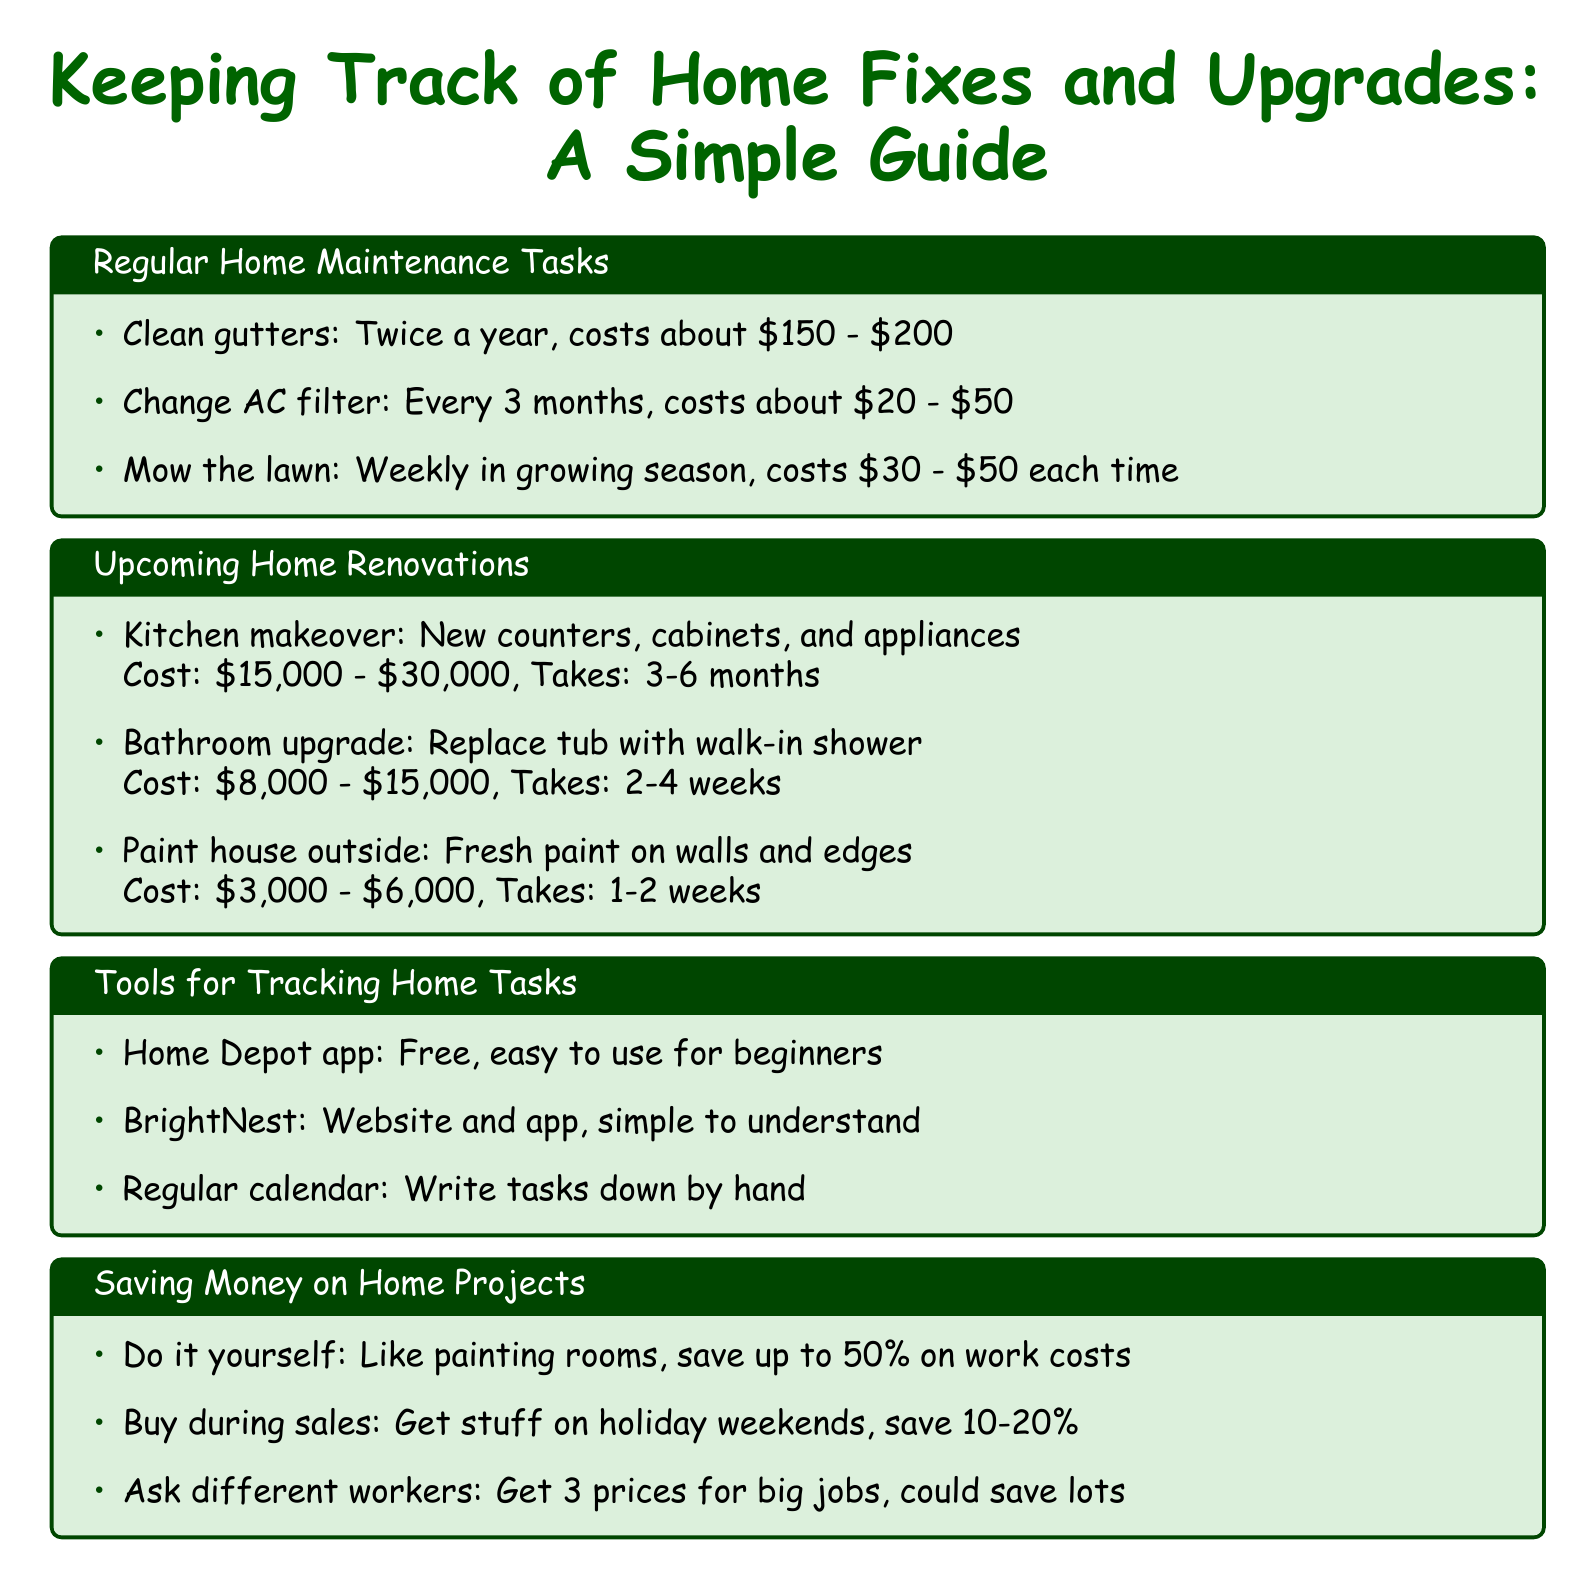What is the cost to clean gutters? The cost to clean gutters is mentioned in the document, which is $150 - $200.
Answer: $150 - $200 How often should you change the HVAC filter? The document specifies that HVAC filters should be replaced every 3 months.
Answer: Every 3 months What is the estimated cost of a kitchen remodel? The document lists the estimated cost for a kitchen remodel as $15,000 - $30,000.
Answer: $15,000 - $30,000 How long does a bathroom upgrade take? The document states that a bathroom upgrade takes 2-4 weeks.
Answer: 2-4 weeks What is one tool for tracking home tasks? The document describes several tools for tracking home tasks, including the Home Depot app.
Answer: Home Depot app What can you potentially save by doing DIY projects? According to the document, you could save up to 50% on labor costs by doing DIY projects.
Answer: Up to 50% Which website/app offers home maintenance reminders? The document mentions BrightNest as a website and app for home maintenance reminders.
Answer: BrightNest What savings can you achieve by shopping sales at Lowe's? The document states that shopping sales at Lowe's can save you 10-20% on supplies.
Answer: 10-20% What is one benefit of using a calendar for tracking tasks? The document notes that a regular calendar allows you to write tasks down by hand, making it straightforward.
Answer: Write tasks down by hand 